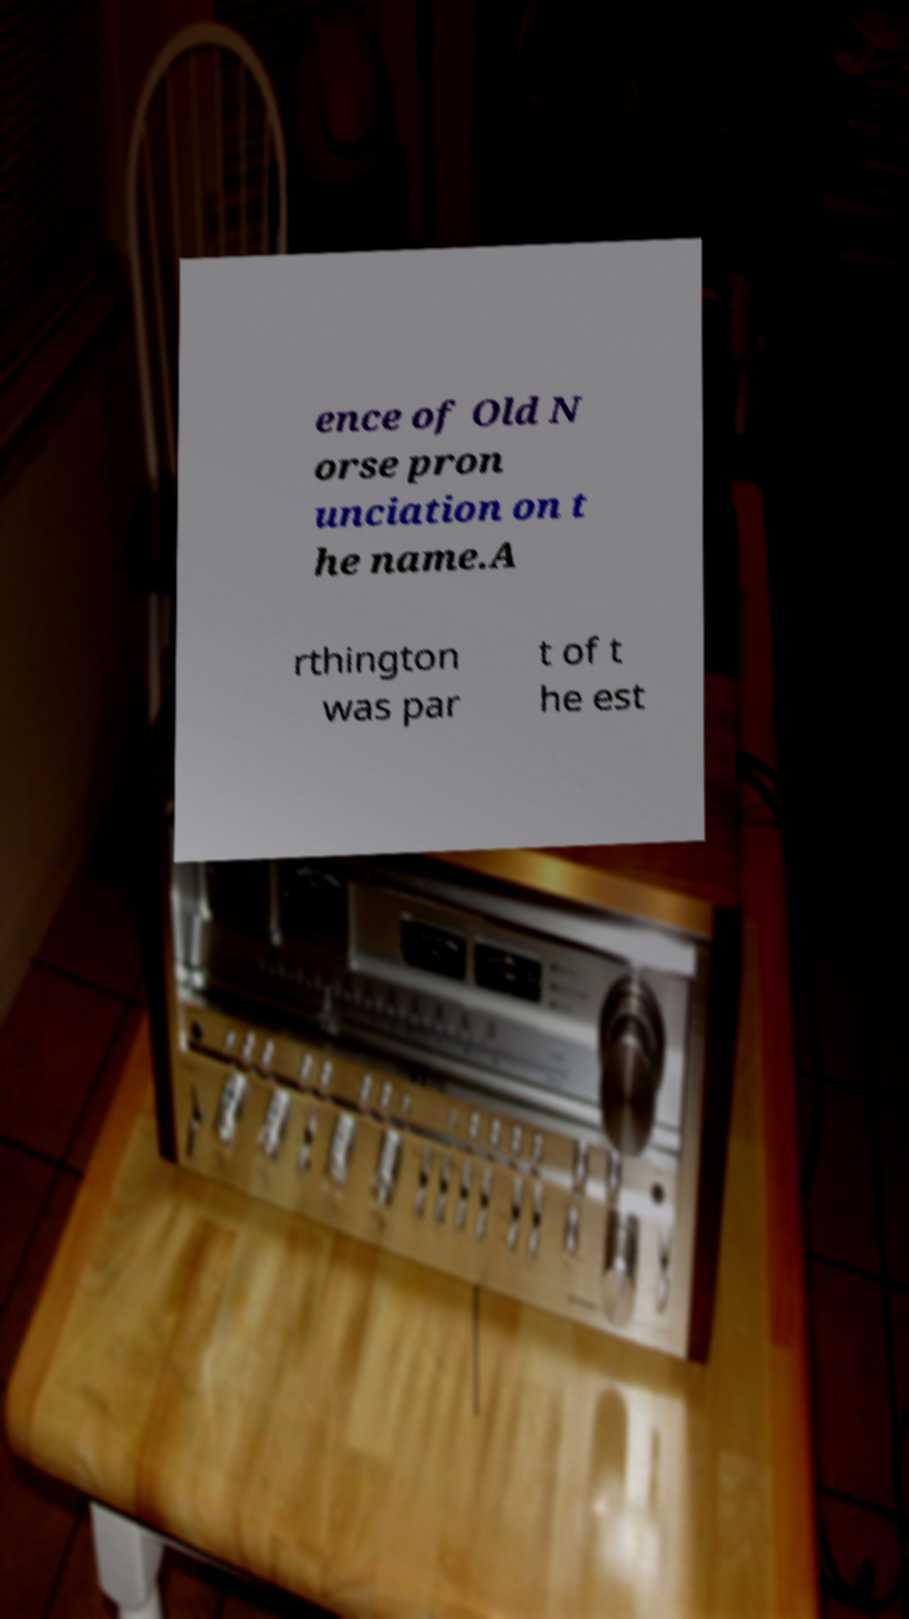Please read and relay the text visible in this image. What does it say? ence of Old N orse pron unciation on t he name.A rthington was par t of t he est 